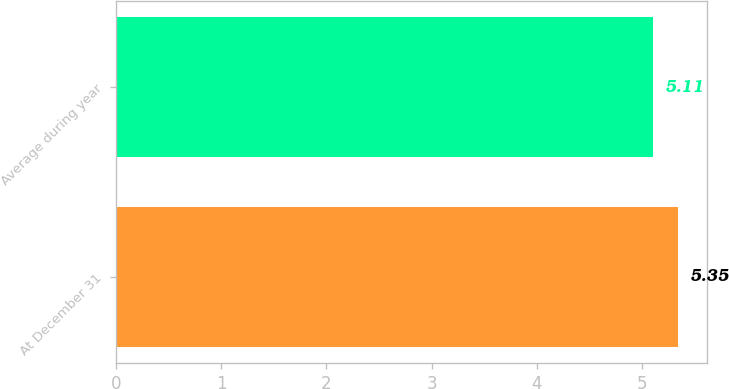Convert chart. <chart><loc_0><loc_0><loc_500><loc_500><bar_chart><fcel>At December 31<fcel>Average during year<nl><fcel>5.35<fcel>5.11<nl></chart> 